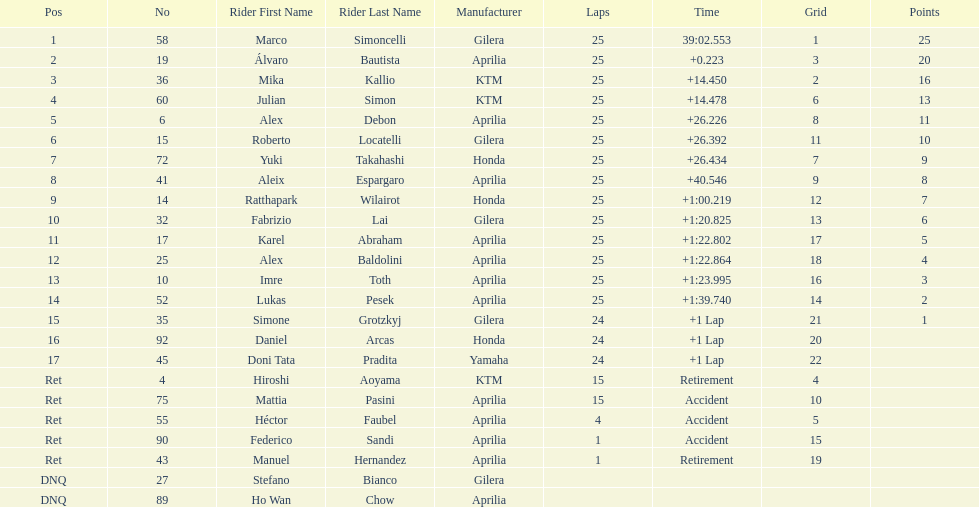How many riders manufacturer is honda? 3. 